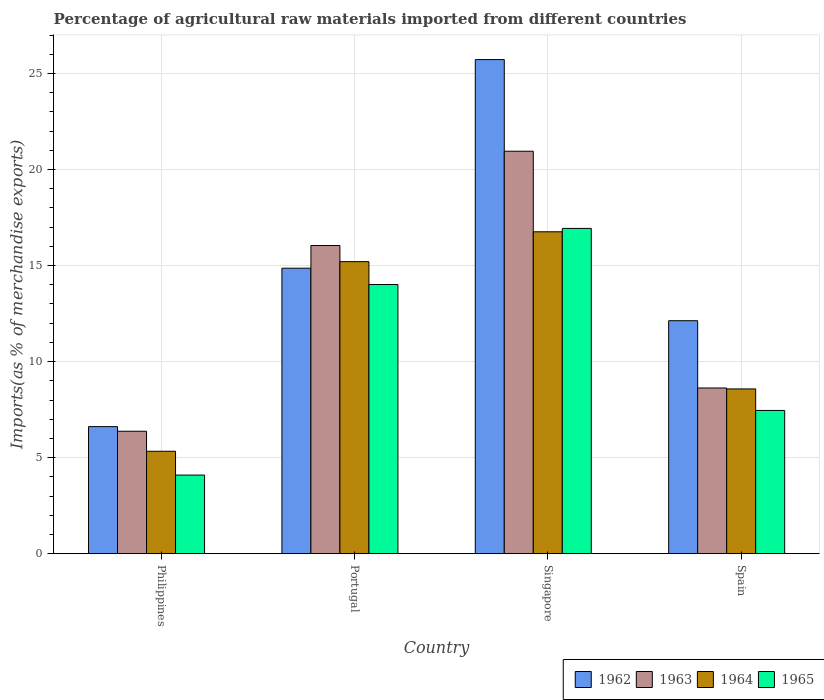How many groups of bars are there?
Your answer should be compact. 4. Are the number of bars per tick equal to the number of legend labels?
Your answer should be very brief. Yes. Are the number of bars on each tick of the X-axis equal?
Give a very brief answer. Yes. How many bars are there on the 4th tick from the left?
Offer a very short reply. 4. What is the label of the 1st group of bars from the left?
Make the answer very short. Philippines. What is the percentage of imports to different countries in 1963 in Portugal?
Provide a succinct answer. 16.04. Across all countries, what is the maximum percentage of imports to different countries in 1965?
Make the answer very short. 16.93. Across all countries, what is the minimum percentage of imports to different countries in 1962?
Provide a short and direct response. 6.61. In which country was the percentage of imports to different countries in 1964 maximum?
Offer a terse response. Singapore. In which country was the percentage of imports to different countries in 1965 minimum?
Your answer should be compact. Philippines. What is the total percentage of imports to different countries in 1965 in the graph?
Give a very brief answer. 42.5. What is the difference between the percentage of imports to different countries in 1965 in Philippines and that in Spain?
Provide a succinct answer. -3.37. What is the difference between the percentage of imports to different countries in 1965 in Philippines and the percentage of imports to different countries in 1963 in Spain?
Offer a very short reply. -4.53. What is the average percentage of imports to different countries in 1964 per country?
Ensure brevity in your answer.  11.47. What is the difference between the percentage of imports to different countries of/in 1963 and percentage of imports to different countries of/in 1964 in Spain?
Ensure brevity in your answer.  0.05. In how many countries, is the percentage of imports to different countries in 1963 greater than 8 %?
Offer a terse response. 3. What is the ratio of the percentage of imports to different countries in 1965 in Philippines to that in Singapore?
Give a very brief answer. 0.24. Is the percentage of imports to different countries in 1964 in Philippines less than that in Portugal?
Offer a very short reply. Yes. Is the difference between the percentage of imports to different countries in 1963 in Singapore and Spain greater than the difference between the percentage of imports to different countries in 1964 in Singapore and Spain?
Provide a succinct answer. Yes. What is the difference between the highest and the second highest percentage of imports to different countries in 1964?
Ensure brevity in your answer.  8.18. What is the difference between the highest and the lowest percentage of imports to different countries in 1965?
Provide a short and direct response. 12.84. In how many countries, is the percentage of imports to different countries in 1962 greater than the average percentage of imports to different countries in 1962 taken over all countries?
Your answer should be compact. 2. What does the 1st bar from the left in Spain represents?
Ensure brevity in your answer.  1962. What does the 3rd bar from the right in Portugal represents?
Provide a succinct answer. 1963. How many bars are there?
Keep it short and to the point. 16. Are all the bars in the graph horizontal?
Your response must be concise. No. How many countries are there in the graph?
Give a very brief answer. 4. What is the difference between two consecutive major ticks on the Y-axis?
Keep it short and to the point. 5. Does the graph contain any zero values?
Give a very brief answer. No. Does the graph contain grids?
Give a very brief answer. Yes. How many legend labels are there?
Your answer should be compact. 4. What is the title of the graph?
Give a very brief answer. Percentage of agricultural raw materials imported from different countries. What is the label or title of the Y-axis?
Make the answer very short. Imports(as % of merchandise exports). What is the Imports(as % of merchandise exports) of 1962 in Philippines?
Offer a terse response. 6.61. What is the Imports(as % of merchandise exports) in 1963 in Philippines?
Make the answer very short. 6.37. What is the Imports(as % of merchandise exports) of 1964 in Philippines?
Your answer should be very brief. 5.33. What is the Imports(as % of merchandise exports) in 1965 in Philippines?
Make the answer very short. 4.09. What is the Imports(as % of merchandise exports) of 1962 in Portugal?
Your answer should be very brief. 14.86. What is the Imports(as % of merchandise exports) of 1963 in Portugal?
Ensure brevity in your answer.  16.04. What is the Imports(as % of merchandise exports) in 1964 in Portugal?
Offer a terse response. 15.2. What is the Imports(as % of merchandise exports) of 1965 in Portugal?
Provide a short and direct response. 14.01. What is the Imports(as % of merchandise exports) in 1962 in Singapore?
Give a very brief answer. 25.73. What is the Imports(as % of merchandise exports) in 1963 in Singapore?
Offer a very short reply. 20.95. What is the Imports(as % of merchandise exports) in 1964 in Singapore?
Ensure brevity in your answer.  16.76. What is the Imports(as % of merchandise exports) in 1965 in Singapore?
Keep it short and to the point. 16.93. What is the Imports(as % of merchandise exports) of 1962 in Spain?
Your answer should be very brief. 12.13. What is the Imports(as % of merchandise exports) of 1963 in Spain?
Make the answer very short. 8.63. What is the Imports(as % of merchandise exports) in 1964 in Spain?
Provide a succinct answer. 8.58. What is the Imports(as % of merchandise exports) of 1965 in Spain?
Your answer should be very brief. 7.46. Across all countries, what is the maximum Imports(as % of merchandise exports) in 1962?
Provide a short and direct response. 25.73. Across all countries, what is the maximum Imports(as % of merchandise exports) in 1963?
Offer a terse response. 20.95. Across all countries, what is the maximum Imports(as % of merchandise exports) in 1964?
Offer a very short reply. 16.76. Across all countries, what is the maximum Imports(as % of merchandise exports) in 1965?
Provide a short and direct response. 16.93. Across all countries, what is the minimum Imports(as % of merchandise exports) in 1962?
Offer a terse response. 6.61. Across all countries, what is the minimum Imports(as % of merchandise exports) in 1963?
Offer a terse response. 6.37. Across all countries, what is the minimum Imports(as % of merchandise exports) of 1964?
Your answer should be compact. 5.33. Across all countries, what is the minimum Imports(as % of merchandise exports) in 1965?
Provide a succinct answer. 4.09. What is the total Imports(as % of merchandise exports) of 1962 in the graph?
Offer a very short reply. 59.33. What is the total Imports(as % of merchandise exports) of 1963 in the graph?
Ensure brevity in your answer.  52. What is the total Imports(as % of merchandise exports) of 1964 in the graph?
Offer a very short reply. 45.87. What is the total Imports(as % of merchandise exports) of 1965 in the graph?
Your answer should be very brief. 42.5. What is the difference between the Imports(as % of merchandise exports) of 1962 in Philippines and that in Portugal?
Offer a very short reply. -8.25. What is the difference between the Imports(as % of merchandise exports) in 1963 in Philippines and that in Portugal?
Make the answer very short. -9.67. What is the difference between the Imports(as % of merchandise exports) of 1964 in Philippines and that in Portugal?
Give a very brief answer. -9.87. What is the difference between the Imports(as % of merchandise exports) of 1965 in Philippines and that in Portugal?
Make the answer very short. -9.92. What is the difference between the Imports(as % of merchandise exports) in 1962 in Philippines and that in Singapore?
Offer a very short reply. -19.11. What is the difference between the Imports(as % of merchandise exports) in 1963 in Philippines and that in Singapore?
Your answer should be compact. -14.58. What is the difference between the Imports(as % of merchandise exports) of 1964 in Philippines and that in Singapore?
Your response must be concise. -11.43. What is the difference between the Imports(as % of merchandise exports) in 1965 in Philippines and that in Singapore?
Ensure brevity in your answer.  -12.84. What is the difference between the Imports(as % of merchandise exports) of 1962 in Philippines and that in Spain?
Offer a very short reply. -5.51. What is the difference between the Imports(as % of merchandise exports) in 1963 in Philippines and that in Spain?
Keep it short and to the point. -2.25. What is the difference between the Imports(as % of merchandise exports) in 1964 in Philippines and that in Spain?
Your answer should be compact. -3.25. What is the difference between the Imports(as % of merchandise exports) of 1965 in Philippines and that in Spain?
Your answer should be very brief. -3.37. What is the difference between the Imports(as % of merchandise exports) in 1962 in Portugal and that in Singapore?
Your answer should be very brief. -10.86. What is the difference between the Imports(as % of merchandise exports) of 1963 in Portugal and that in Singapore?
Provide a short and direct response. -4.91. What is the difference between the Imports(as % of merchandise exports) of 1964 in Portugal and that in Singapore?
Your answer should be compact. -1.55. What is the difference between the Imports(as % of merchandise exports) of 1965 in Portugal and that in Singapore?
Ensure brevity in your answer.  -2.92. What is the difference between the Imports(as % of merchandise exports) in 1962 in Portugal and that in Spain?
Provide a short and direct response. 2.73. What is the difference between the Imports(as % of merchandise exports) in 1963 in Portugal and that in Spain?
Your answer should be compact. 7.42. What is the difference between the Imports(as % of merchandise exports) of 1964 in Portugal and that in Spain?
Keep it short and to the point. 6.63. What is the difference between the Imports(as % of merchandise exports) of 1965 in Portugal and that in Spain?
Provide a succinct answer. 6.56. What is the difference between the Imports(as % of merchandise exports) of 1962 in Singapore and that in Spain?
Give a very brief answer. 13.6. What is the difference between the Imports(as % of merchandise exports) in 1963 in Singapore and that in Spain?
Make the answer very short. 12.33. What is the difference between the Imports(as % of merchandise exports) of 1964 in Singapore and that in Spain?
Provide a short and direct response. 8.18. What is the difference between the Imports(as % of merchandise exports) in 1965 in Singapore and that in Spain?
Keep it short and to the point. 9.48. What is the difference between the Imports(as % of merchandise exports) in 1962 in Philippines and the Imports(as % of merchandise exports) in 1963 in Portugal?
Offer a terse response. -9.43. What is the difference between the Imports(as % of merchandise exports) of 1962 in Philippines and the Imports(as % of merchandise exports) of 1964 in Portugal?
Your answer should be compact. -8.59. What is the difference between the Imports(as % of merchandise exports) of 1962 in Philippines and the Imports(as % of merchandise exports) of 1965 in Portugal?
Your response must be concise. -7.4. What is the difference between the Imports(as % of merchandise exports) in 1963 in Philippines and the Imports(as % of merchandise exports) in 1964 in Portugal?
Offer a terse response. -8.83. What is the difference between the Imports(as % of merchandise exports) of 1963 in Philippines and the Imports(as % of merchandise exports) of 1965 in Portugal?
Offer a very short reply. -7.64. What is the difference between the Imports(as % of merchandise exports) of 1964 in Philippines and the Imports(as % of merchandise exports) of 1965 in Portugal?
Your answer should be very brief. -8.68. What is the difference between the Imports(as % of merchandise exports) in 1962 in Philippines and the Imports(as % of merchandise exports) in 1963 in Singapore?
Provide a short and direct response. -14.34. What is the difference between the Imports(as % of merchandise exports) in 1962 in Philippines and the Imports(as % of merchandise exports) in 1964 in Singapore?
Keep it short and to the point. -10.14. What is the difference between the Imports(as % of merchandise exports) of 1962 in Philippines and the Imports(as % of merchandise exports) of 1965 in Singapore?
Offer a very short reply. -10.32. What is the difference between the Imports(as % of merchandise exports) in 1963 in Philippines and the Imports(as % of merchandise exports) in 1964 in Singapore?
Your answer should be compact. -10.39. What is the difference between the Imports(as % of merchandise exports) of 1963 in Philippines and the Imports(as % of merchandise exports) of 1965 in Singapore?
Ensure brevity in your answer.  -10.56. What is the difference between the Imports(as % of merchandise exports) in 1964 in Philippines and the Imports(as % of merchandise exports) in 1965 in Singapore?
Offer a terse response. -11.6. What is the difference between the Imports(as % of merchandise exports) in 1962 in Philippines and the Imports(as % of merchandise exports) in 1963 in Spain?
Provide a succinct answer. -2.01. What is the difference between the Imports(as % of merchandise exports) of 1962 in Philippines and the Imports(as % of merchandise exports) of 1964 in Spain?
Ensure brevity in your answer.  -1.96. What is the difference between the Imports(as % of merchandise exports) in 1962 in Philippines and the Imports(as % of merchandise exports) in 1965 in Spain?
Keep it short and to the point. -0.84. What is the difference between the Imports(as % of merchandise exports) of 1963 in Philippines and the Imports(as % of merchandise exports) of 1964 in Spain?
Ensure brevity in your answer.  -2.2. What is the difference between the Imports(as % of merchandise exports) in 1963 in Philippines and the Imports(as % of merchandise exports) in 1965 in Spain?
Offer a very short reply. -1.08. What is the difference between the Imports(as % of merchandise exports) of 1964 in Philippines and the Imports(as % of merchandise exports) of 1965 in Spain?
Provide a short and direct response. -2.13. What is the difference between the Imports(as % of merchandise exports) in 1962 in Portugal and the Imports(as % of merchandise exports) in 1963 in Singapore?
Give a very brief answer. -6.09. What is the difference between the Imports(as % of merchandise exports) in 1962 in Portugal and the Imports(as % of merchandise exports) in 1964 in Singapore?
Your answer should be very brief. -1.9. What is the difference between the Imports(as % of merchandise exports) of 1962 in Portugal and the Imports(as % of merchandise exports) of 1965 in Singapore?
Your answer should be compact. -2.07. What is the difference between the Imports(as % of merchandise exports) in 1963 in Portugal and the Imports(as % of merchandise exports) in 1964 in Singapore?
Offer a terse response. -0.72. What is the difference between the Imports(as % of merchandise exports) of 1963 in Portugal and the Imports(as % of merchandise exports) of 1965 in Singapore?
Your response must be concise. -0.89. What is the difference between the Imports(as % of merchandise exports) in 1964 in Portugal and the Imports(as % of merchandise exports) in 1965 in Singapore?
Give a very brief answer. -1.73. What is the difference between the Imports(as % of merchandise exports) of 1962 in Portugal and the Imports(as % of merchandise exports) of 1963 in Spain?
Offer a terse response. 6.24. What is the difference between the Imports(as % of merchandise exports) in 1962 in Portugal and the Imports(as % of merchandise exports) in 1964 in Spain?
Keep it short and to the point. 6.28. What is the difference between the Imports(as % of merchandise exports) of 1962 in Portugal and the Imports(as % of merchandise exports) of 1965 in Spain?
Offer a very short reply. 7.41. What is the difference between the Imports(as % of merchandise exports) of 1963 in Portugal and the Imports(as % of merchandise exports) of 1964 in Spain?
Ensure brevity in your answer.  7.47. What is the difference between the Imports(as % of merchandise exports) of 1963 in Portugal and the Imports(as % of merchandise exports) of 1965 in Spain?
Provide a succinct answer. 8.59. What is the difference between the Imports(as % of merchandise exports) in 1964 in Portugal and the Imports(as % of merchandise exports) in 1965 in Spain?
Provide a succinct answer. 7.75. What is the difference between the Imports(as % of merchandise exports) in 1962 in Singapore and the Imports(as % of merchandise exports) in 1963 in Spain?
Your answer should be compact. 17.1. What is the difference between the Imports(as % of merchandise exports) of 1962 in Singapore and the Imports(as % of merchandise exports) of 1964 in Spain?
Ensure brevity in your answer.  17.15. What is the difference between the Imports(as % of merchandise exports) of 1962 in Singapore and the Imports(as % of merchandise exports) of 1965 in Spain?
Provide a succinct answer. 18.27. What is the difference between the Imports(as % of merchandise exports) of 1963 in Singapore and the Imports(as % of merchandise exports) of 1964 in Spain?
Ensure brevity in your answer.  12.38. What is the difference between the Imports(as % of merchandise exports) in 1963 in Singapore and the Imports(as % of merchandise exports) in 1965 in Spain?
Give a very brief answer. 13.5. What is the difference between the Imports(as % of merchandise exports) of 1964 in Singapore and the Imports(as % of merchandise exports) of 1965 in Spain?
Give a very brief answer. 9.3. What is the average Imports(as % of merchandise exports) of 1962 per country?
Your answer should be very brief. 14.83. What is the average Imports(as % of merchandise exports) in 1963 per country?
Offer a terse response. 13. What is the average Imports(as % of merchandise exports) in 1964 per country?
Keep it short and to the point. 11.47. What is the average Imports(as % of merchandise exports) of 1965 per country?
Make the answer very short. 10.62. What is the difference between the Imports(as % of merchandise exports) in 1962 and Imports(as % of merchandise exports) in 1963 in Philippines?
Keep it short and to the point. 0.24. What is the difference between the Imports(as % of merchandise exports) in 1962 and Imports(as % of merchandise exports) in 1964 in Philippines?
Ensure brevity in your answer.  1.28. What is the difference between the Imports(as % of merchandise exports) of 1962 and Imports(as % of merchandise exports) of 1965 in Philippines?
Provide a short and direct response. 2.52. What is the difference between the Imports(as % of merchandise exports) of 1963 and Imports(as % of merchandise exports) of 1964 in Philippines?
Provide a short and direct response. 1.04. What is the difference between the Imports(as % of merchandise exports) of 1963 and Imports(as % of merchandise exports) of 1965 in Philippines?
Your response must be concise. 2.28. What is the difference between the Imports(as % of merchandise exports) in 1964 and Imports(as % of merchandise exports) in 1965 in Philippines?
Offer a very short reply. 1.24. What is the difference between the Imports(as % of merchandise exports) in 1962 and Imports(as % of merchandise exports) in 1963 in Portugal?
Give a very brief answer. -1.18. What is the difference between the Imports(as % of merchandise exports) in 1962 and Imports(as % of merchandise exports) in 1964 in Portugal?
Your answer should be compact. -0.34. What is the difference between the Imports(as % of merchandise exports) of 1962 and Imports(as % of merchandise exports) of 1965 in Portugal?
Provide a short and direct response. 0.85. What is the difference between the Imports(as % of merchandise exports) in 1963 and Imports(as % of merchandise exports) in 1964 in Portugal?
Provide a short and direct response. 0.84. What is the difference between the Imports(as % of merchandise exports) in 1963 and Imports(as % of merchandise exports) in 1965 in Portugal?
Your answer should be compact. 2.03. What is the difference between the Imports(as % of merchandise exports) of 1964 and Imports(as % of merchandise exports) of 1965 in Portugal?
Your response must be concise. 1.19. What is the difference between the Imports(as % of merchandise exports) of 1962 and Imports(as % of merchandise exports) of 1963 in Singapore?
Give a very brief answer. 4.77. What is the difference between the Imports(as % of merchandise exports) in 1962 and Imports(as % of merchandise exports) in 1964 in Singapore?
Offer a terse response. 8.97. What is the difference between the Imports(as % of merchandise exports) in 1962 and Imports(as % of merchandise exports) in 1965 in Singapore?
Offer a very short reply. 8.79. What is the difference between the Imports(as % of merchandise exports) in 1963 and Imports(as % of merchandise exports) in 1964 in Singapore?
Keep it short and to the point. 4.19. What is the difference between the Imports(as % of merchandise exports) in 1963 and Imports(as % of merchandise exports) in 1965 in Singapore?
Offer a terse response. 4.02. What is the difference between the Imports(as % of merchandise exports) in 1964 and Imports(as % of merchandise exports) in 1965 in Singapore?
Ensure brevity in your answer.  -0.18. What is the difference between the Imports(as % of merchandise exports) in 1962 and Imports(as % of merchandise exports) in 1963 in Spain?
Offer a terse response. 3.5. What is the difference between the Imports(as % of merchandise exports) in 1962 and Imports(as % of merchandise exports) in 1964 in Spain?
Provide a succinct answer. 3.55. What is the difference between the Imports(as % of merchandise exports) in 1962 and Imports(as % of merchandise exports) in 1965 in Spain?
Provide a short and direct response. 4.67. What is the difference between the Imports(as % of merchandise exports) of 1963 and Imports(as % of merchandise exports) of 1964 in Spain?
Your answer should be compact. 0.05. What is the difference between the Imports(as % of merchandise exports) in 1963 and Imports(as % of merchandise exports) in 1965 in Spain?
Give a very brief answer. 1.17. What is the difference between the Imports(as % of merchandise exports) in 1964 and Imports(as % of merchandise exports) in 1965 in Spain?
Make the answer very short. 1.12. What is the ratio of the Imports(as % of merchandise exports) in 1962 in Philippines to that in Portugal?
Keep it short and to the point. 0.45. What is the ratio of the Imports(as % of merchandise exports) of 1963 in Philippines to that in Portugal?
Keep it short and to the point. 0.4. What is the ratio of the Imports(as % of merchandise exports) of 1964 in Philippines to that in Portugal?
Your answer should be very brief. 0.35. What is the ratio of the Imports(as % of merchandise exports) in 1965 in Philippines to that in Portugal?
Keep it short and to the point. 0.29. What is the ratio of the Imports(as % of merchandise exports) of 1962 in Philippines to that in Singapore?
Give a very brief answer. 0.26. What is the ratio of the Imports(as % of merchandise exports) of 1963 in Philippines to that in Singapore?
Keep it short and to the point. 0.3. What is the ratio of the Imports(as % of merchandise exports) of 1964 in Philippines to that in Singapore?
Offer a terse response. 0.32. What is the ratio of the Imports(as % of merchandise exports) of 1965 in Philippines to that in Singapore?
Offer a very short reply. 0.24. What is the ratio of the Imports(as % of merchandise exports) of 1962 in Philippines to that in Spain?
Offer a very short reply. 0.55. What is the ratio of the Imports(as % of merchandise exports) in 1963 in Philippines to that in Spain?
Keep it short and to the point. 0.74. What is the ratio of the Imports(as % of merchandise exports) in 1964 in Philippines to that in Spain?
Make the answer very short. 0.62. What is the ratio of the Imports(as % of merchandise exports) of 1965 in Philippines to that in Spain?
Provide a succinct answer. 0.55. What is the ratio of the Imports(as % of merchandise exports) of 1962 in Portugal to that in Singapore?
Offer a very short reply. 0.58. What is the ratio of the Imports(as % of merchandise exports) of 1963 in Portugal to that in Singapore?
Your answer should be very brief. 0.77. What is the ratio of the Imports(as % of merchandise exports) of 1964 in Portugal to that in Singapore?
Your answer should be very brief. 0.91. What is the ratio of the Imports(as % of merchandise exports) in 1965 in Portugal to that in Singapore?
Provide a short and direct response. 0.83. What is the ratio of the Imports(as % of merchandise exports) in 1962 in Portugal to that in Spain?
Offer a terse response. 1.23. What is the ratio of the Imports(as % of merchandise exports) in 1963 in Portugal to that in Spain?
Ensure brevity in your answer.  1.86. What is the ratio of the Imports(as % of merchandise exports) of 1964 in Portugal to that in Spain?
Provide a short and direct response. 1.77. What is the ratio of the Imports(as % of merchandise exports) of 1965 in Portugal to that in Spain?
Your answer should be very brief. 1.88. What is the ratio of the Imports(as % of merchandise exports) in 1962 in Singapore to that in Spain?
Make the answer very short. 2.12. What is the ratio of the Imports(as % of merchandise exports) in 1963 in Singapore to that in Spain?
Offer a very short reply. 2.43. What is the ratio of the Imports(as % of merchandise exports) of 1964 in Singapore to that in Spain?
Give a very brief answer. 1.95. What is the ratio of the Imports(as % of merchandise exports) in 1965 in Singapore to that in Spain?
Give a very brief answer. 2.27. What is the difference between the highest and the second highest Imports(as % of merchandise exports) in 1962?
Your answer should be very brief. 10.86. What is the difference between the highest and the second highest Imports(as % of merchandise exports) in 1963?
Make the answer very short. 4.91. What is the difference between the highest and the second highest Imports(as % of merchandise exports) of 1964?
Your answer should be compact. 1.55. What is the difference between the highest and the second highest Imports(as % of merchandise exports) in 1965?
Provide a short and direct response. 2.92. What is the difference between the highest and the lowest Imports(as % of merchandise exports) in 1962?
Give a very brief answer. 19.11. What is the difference between the highest and the lowest Imports(as % of merchandise exports) in 1963?
Offer a very short reply. 14.58. What is the difference between the highest and the lowest Imports(as % of merchandise exports) in 1964?
Your response must be concise. 11.43. What is the difference between the highest and the lowest Imports(as % of merchandise exports) in 1965?
Offer a terse response. 12.84. 